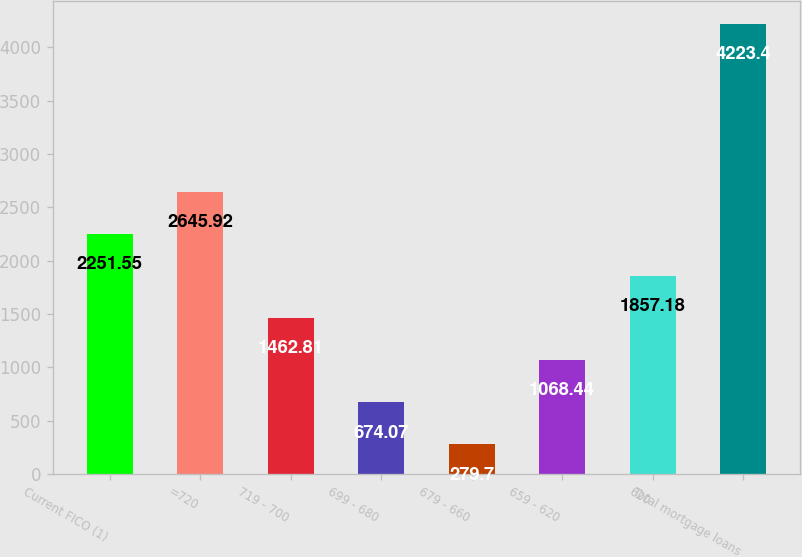Convert chart. <chart><loc_0><loc_0><loc_500><loc_500><bar_chart><fcel>Current FICO (1)<fcel>=720<fcel>719 - 700<fcel>699 - 680<fcel>679 - 660<fcel>659 - 620<fcel>620<fcel>Total mortgage loans<nl><fcel>2251.55<fcel>2645.92<fcel>1462.81<fcel>674.07<fcel>279.7<fcel>1068.44<fcel>1857.18<fcel>4223.4<nl></chart> 